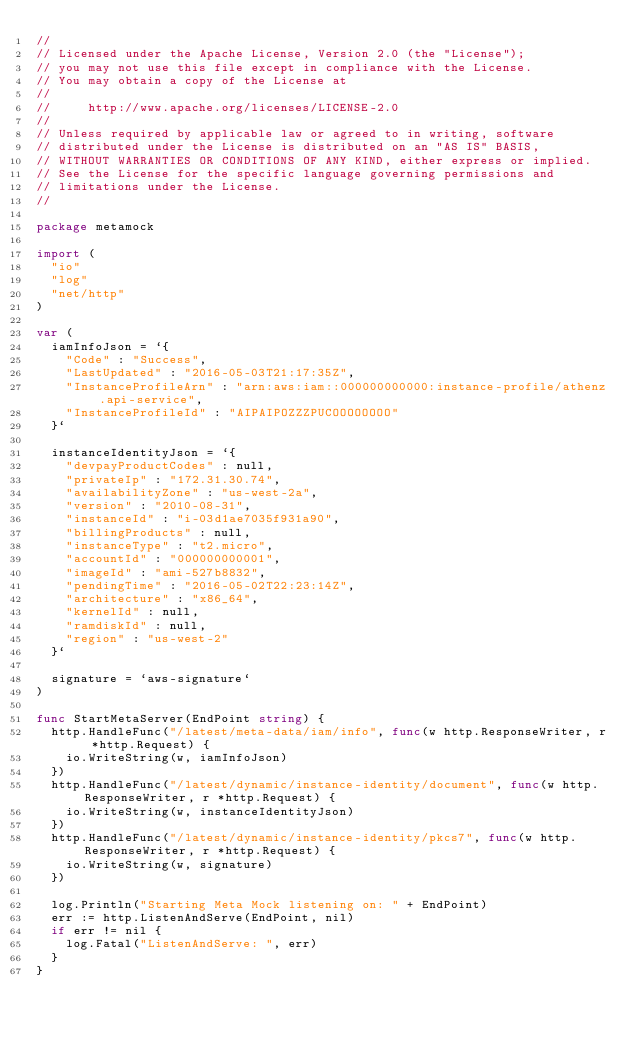Convert code to text. <code><loc_0><loc_0><loc_500><loc_500><_Go_>//
// Licensed under the Apache License, Version 2.0 (the "License");
// you may not use this file except in compliance with the License.
// You may obtain a copy of the License at
//
//     http://www.apache.org/licenses/LICENSE-2.0
//
// Unless required by applicable law or agreed to in writing, software
// distributed under the License is distributed on an "AS IS" BASIS,
// WITHOUT WARRANTIES OR CONDITIONS OF ANY KIND, either express or implied.
// See the License for the specific language governing permissions and
// limitations under the License.
//

package metamock

import (
	"io"
	"log"
	"net/http"
)

var (
	iamInfoJson = `{
		"Code" : "Success",
		"LastUpdated" : "2016-05-03T21:17:35Z",
		"InstanceProfileArn" : "arn:aws:iam::000000000000:instance-profile/athenz.api-service",
		"InstanceProfileId" : "AIPAIPOZZZPUCOOOOOOOO"
	}`

	instanceIdentityJson = `{
		"devpayProductCodes" : null,
		"privateIp" : "172.31.30.74",
		"availabilityZone" : "us-west-2a",
		"version" : "2010-08-31",
		"instanceId" : "i-03d1ae7035f931a90",
		"billingProducts" : null,
		"instanceType" : "t2.micro",
		"accountId" : "000000000001",
		"imageId" : "ami-527b8832",
		"pendingTime" : "2016-05-02T22:23:14Z",
		"architecture" : "x86_64",
		"kernelId" : null,
		"ramdiskId" : null,
		"region" : "us-west-2"
	}`

	signature = `aws-signature`
)

func StartMetaServer(EndPoint string) {
	http.HandleFunc("/latest/meta-data/iam/info", func(w http.ResponseWriter, r *http.Request) {
		io.WriteString(w, iamInfoJson)
	})
	http.HandleFunc("/latest/dynamic/instance-identity/document", func(w http.ResponseWriter, r *http.Request) {
		io.WriteString(w, instanceIdentityJson)
	})
	http.HandleFunc("/latest/dynamic/instance-identity/pkcs7", func(w http.ResponseWriter, r *http.Request) {
		io.WriteString(w, signature)
	})

	log.Println("Starting Meta Mock listening on: " + EndPoint)
	err := http.ListenAndServe(EndPoint, nil)
	if err != nil {
		log.Fatal("ListenAndServe: ", err)
	}
}
</code> 